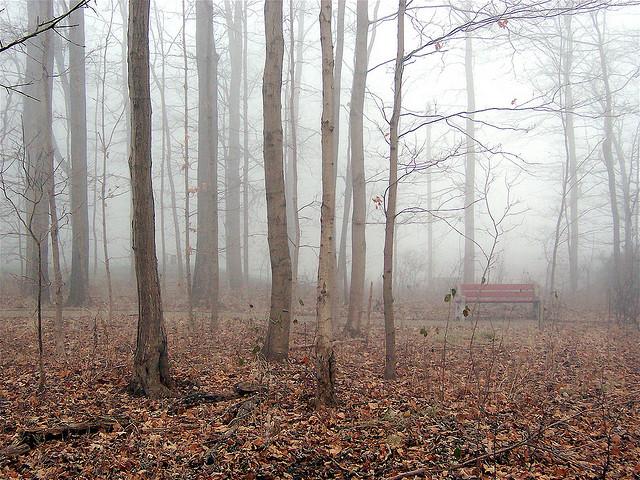Is the ground right-side up?
Quick response, please. Yes. Is anyone sitting on the bench?
Give a very brief answer. No. Is there lots of trees?
Answer briefly. Yes. How much grass is there?
Answer briefly. 0. Are the trees bare?
Be succinct. Yes. What is on the ground?
Give a very brief answer. Leaves. 